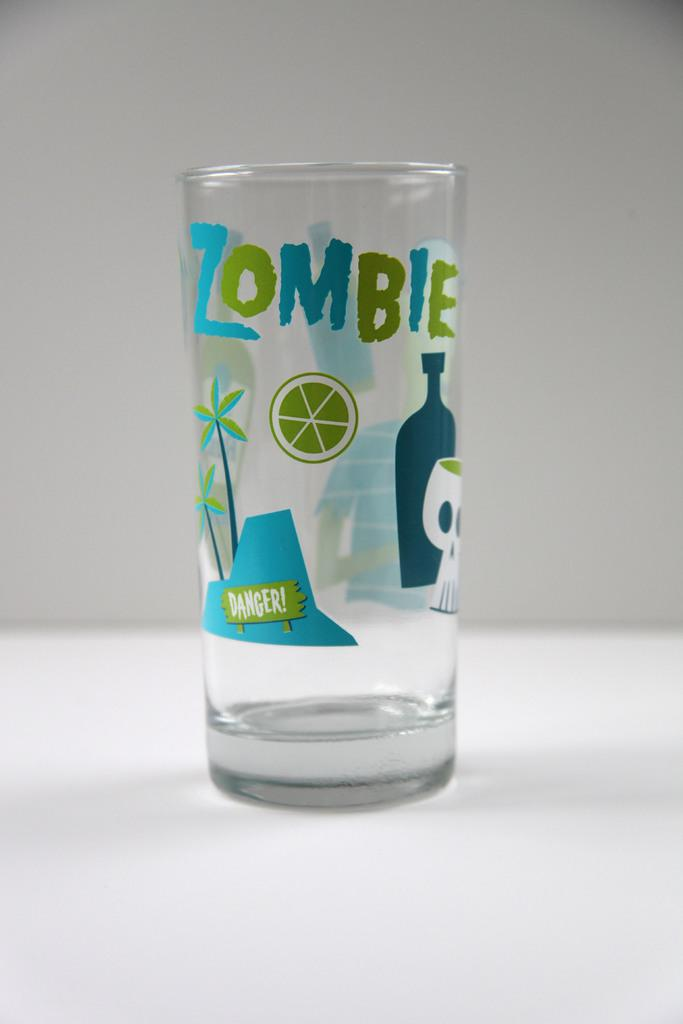<image>
Create a compact narrative representing the image presented. A Clear glass is displayed that says Zombie on it 